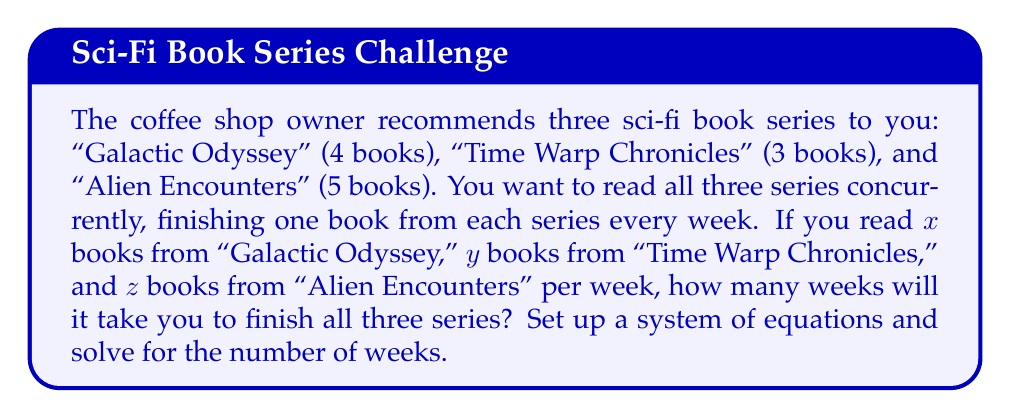Solve this math problem. Let's approach this step-by-step:

1) First, we need to set up our system of equations. We know that:
   - You read $x$ books from "Galactic Odyssey" per week
   - You read $y$ books from "Time Warp Chronicles" per week
   - You read $z$ books from "Alien Encounters" per week
   - You read one book from each series every week

2) Let $w$ be the number of weeks it takes to finish all series. We can set up the following equations:

   $$4 = xw$$ (Galactic Odyssey)
   $$3 = yw$$ (Time Warp Chronicles)
   $$5 = zw$$ (Alien Encounters)
   $$x + y + z = 1$$ (One book from each series per week)

3) From the first three equations, we can express $x$, $y$, and $z$ in terms of $w$:

   $$x = \frac{4}{w}$$
   $$y = \frac{3}{w}$$
   $$z = \frac{5}{w}$$

4) Substituting these into the fourth equation:

   $$\frac{4}{w} + \frac{3}{w} + \frac{5}{w} = 1$$

5) Simplifying:

   $$\frac{12}{w} = 1$$

6) Solving for $w$:

   $$w = 12$$

Therefore, it will take 12 weeks to finish all three series.
Answer: 12 weeks 